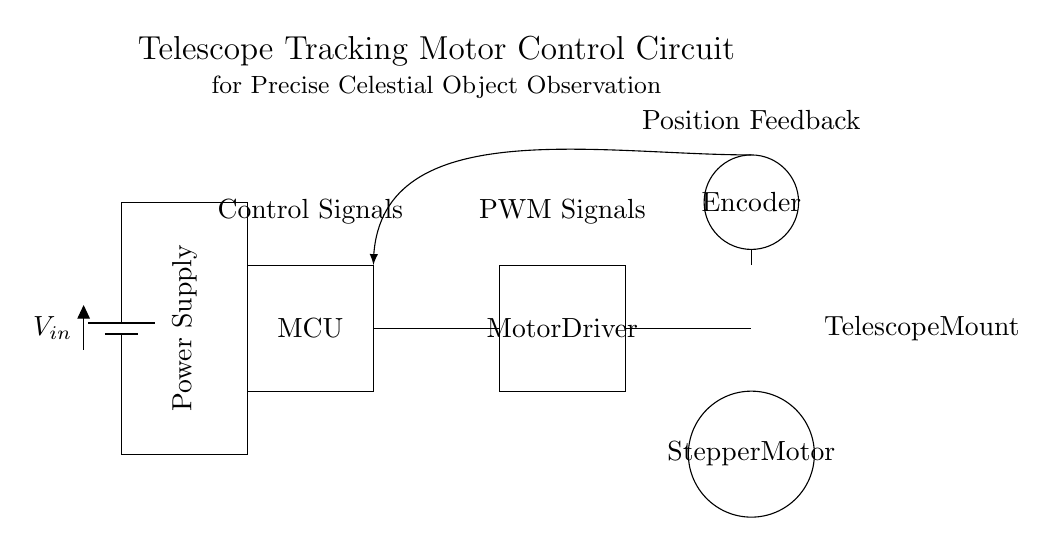What is the main control unit in this circuit? The main control unit is labeled as "MCU," which stands for Microcontroller. It is responsible for processing the control signals that dictate the motor's operation.
Answer: MCU What type of motor is used in this circuit? The type of motor used is indicated as "Stepper Motor" in the diagram. Stepper motors are commonly used for precise control of angular position, which is essential for telescope tracking.
Answer: Stepper Motor How does the system receive position feedback? The position feedback is received from the "Encoder" component in the circuit. The encoder measures the position of the motor shaft and provides relevant feedback to the control unit for precision tracking.
Answer: Encoder What signals does the Motor Driver receive from the MCU? The Motor Driver receives "PWM Signals" from the MCU. PWM, or Pulse Width Modulation, is used to control the motor's speed and position accurately.
Answer: PWM Signals What is the purpose of the battery in this circuit? The battery, labeled as "V_in," provides the necessary power supply for the entire circuit, ensuring that all components, including the MCU, Motor Driver, and Stepper Motor, have the energy needed to function.
Answer: V_in Why is there a feedback loop present in this circuit? The feedback loop is present to automatically adjust the control signals based on the position feedback from the encoder, enhancing the precision of the motor's positioning for accurate celestial observations.
Answer: Feedback loop 